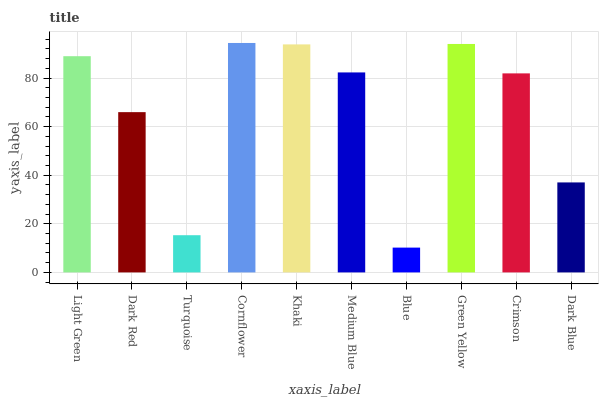Is Blue the minimum?
Answer yes or no. Yes. Is Cornflower the maximum?
Answer yes or no. Yes. Is Dark Red the minimum?
Answer yes or no. No. Is Dark Red the maximum?
Answer yes or no. No. Is Light Green greater than Dark Red?
Answer yes or no. Yes. Is Dark Red less than Light Green?
Answer yes or no. Yes. Is Dark Red greater than Light Green?
Answer yes or no. No. Is Light Green less than Dark Red?
Answer yes or no. No. Is Medium Blue the high median?
Answer yes or no. Yes. Is Crimson the low median?
Answer yes or no. Yes. Is Crimson the high median?
Answer yes or no. No. Is Turquoise the low median?
Answer yes or no. No. 